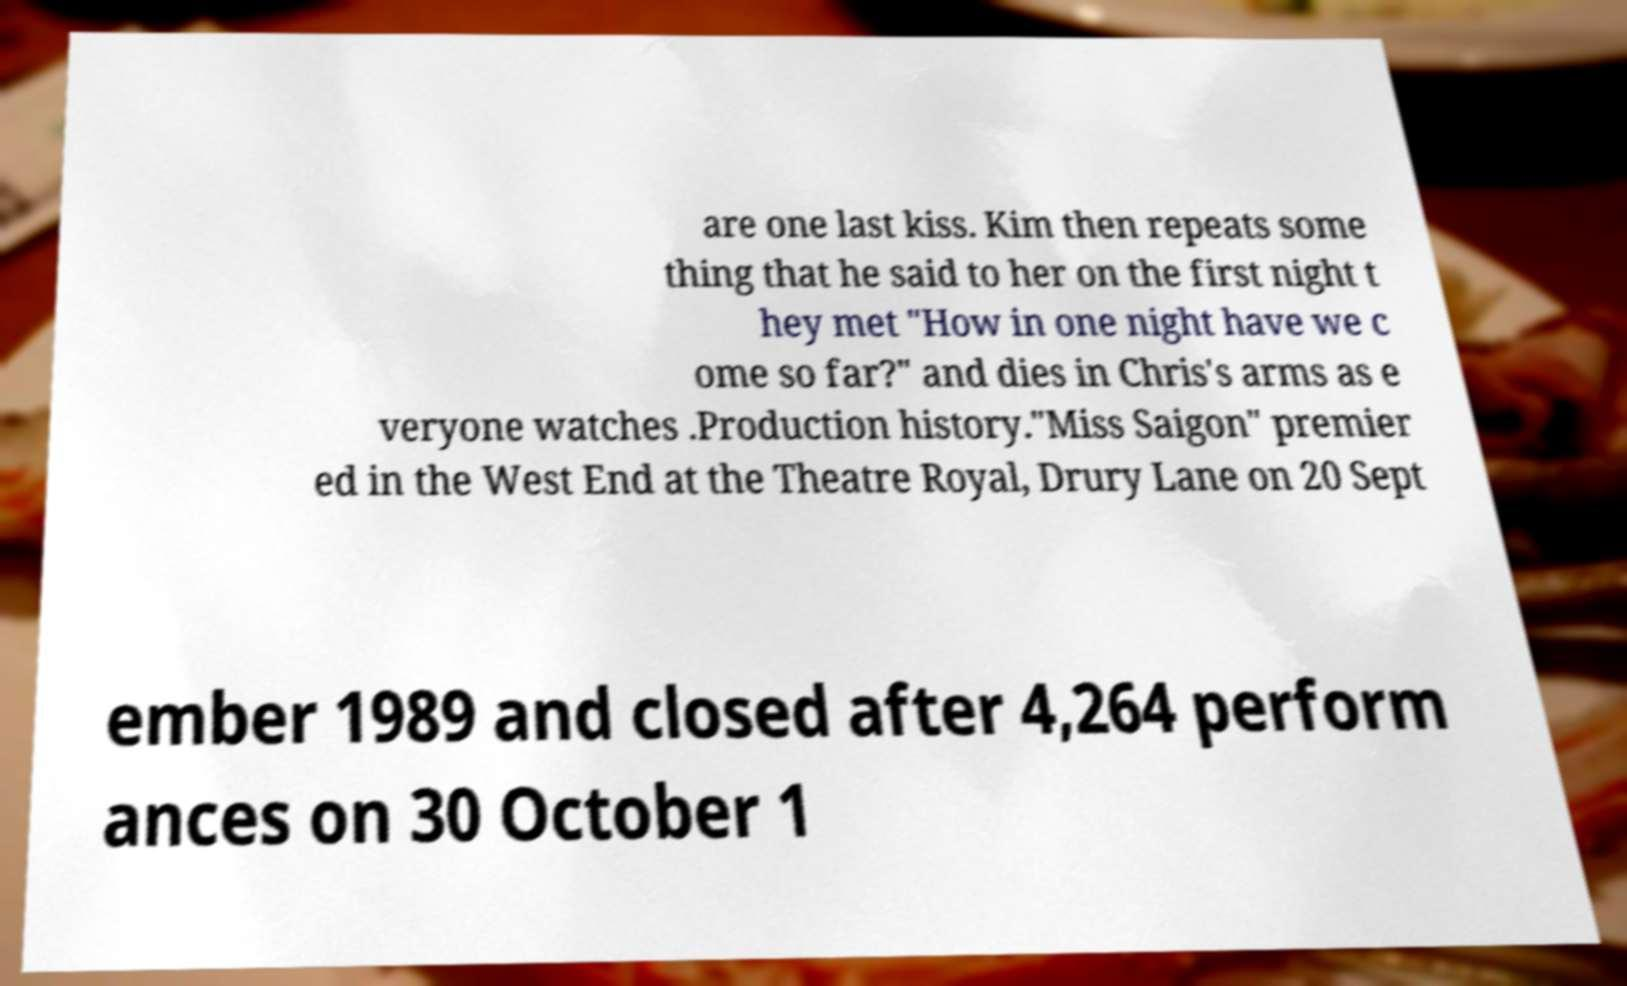Can you read and provide the text displayed in the image?This photo seems to have some interesting text. Can you extract and type it out for me? are one last kiss. Kim then repeats some thing that he said to her on the first night t hey met "How in one night have we c ome so far?" and dies in Chris's arms as e veryone watches .Production history."Miss Saigon" premier ed in the West End at the Theatre Royal, Drury Lane on 20 Sept ember 1989 and closed after 4,264 perform ances on 30 October 1 